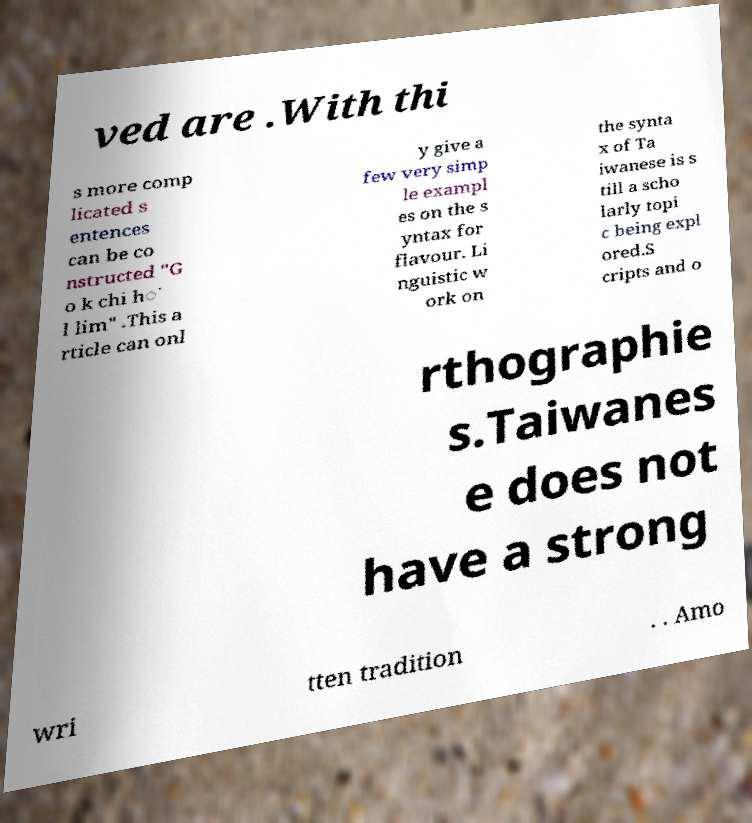Can you read and provide the text displayed in the image?This photo seems to have some interesting text. Can you extract and type it out for me? ved are .With thi s more comp licated s entences can be co nstructed "G o k chi h͘ l lim" .This a rticle can onl y give a few very simp le exampl es on the s yntax for flavour. Li nguistic w ork on the synta x of Ta iwanese is s till a scho larly topi c being expl ored.S cripts and o rthographie s.Taiwanes e does not have a strong wri tten tradition . . Amo 